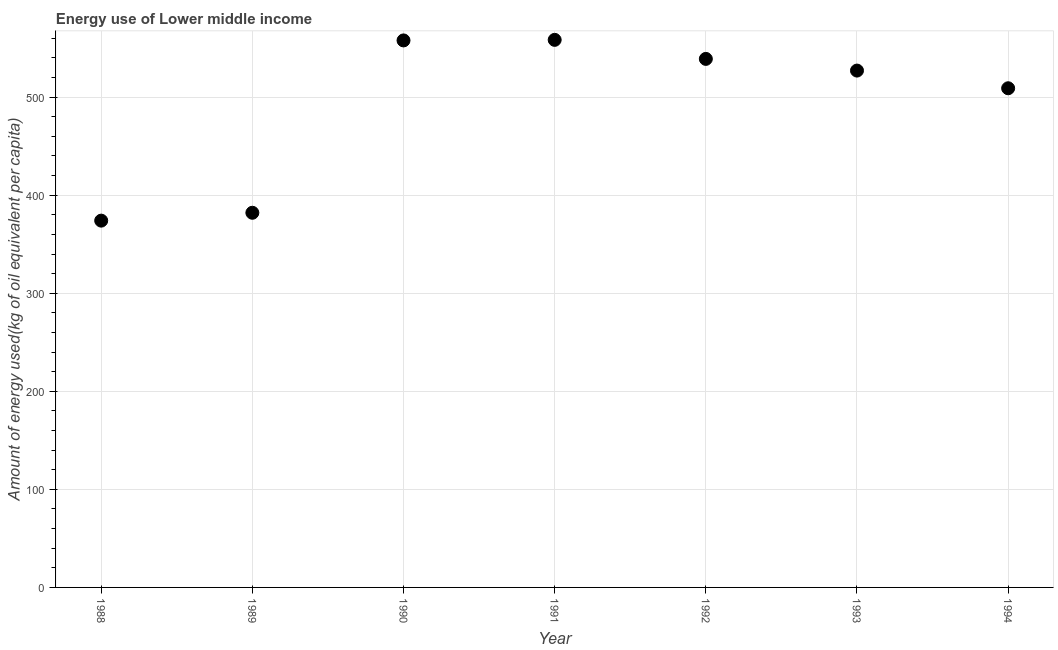What is the amount of energy used in 1989?
Provide a succinct answer. 382.1. Across all years, what is the maximum amount of energy used?
Your response must be concise. 558.43. Across all years, what is the minimum amount of energy used?
Your answer should be compact. 374.07. In which year was the amount of energy used maximum?
Make the answer very short. 1991. In which year was the amount of energy used minimum?
Your answer should be very brief. 1988. What is the sum of the amount of energy used?
Provide a short and direct response. 3447.65. What is the difference between the amount of energy used in 1991 and 1994?
Make the answer very short. 49.36. What is the average amount of energy used per year?
Provide a succinct answer. 492.52. What is the median amount of energy used?
Make the answer very short. 527.1. What is the ratio of the amount of energy used in 1991 to that in 1993?
Make the answer very short. 1.06. What is the difference between the highest and the second highest amount of energy used?
Ensure brevity in your answer.  0.57. Is the sum of the amount of energy used in 1990 and 1993 greater than the maximum amount of energy used across all years?
Your answer should be very brief. Yes. What is the difference between the highest and the lowest amount of energy used?
Provide a short and direct response. 184.36. How many years are there in the graph?
Provide a succinct answer. 7. What is the difference between two consecutive major ticks on the Y-axis?
Your answer should be very brief. 100. Are the values on the major ticks of Y-axis written in scientific E-notation?
Offer a terse response. No. Does the graph contain any zero values?
Provide a succinct answer. No. Does the graph contain grids?
Ensure brevity in your answer.  Yes. What is the title of the graph?
Your answer should be compact. Energy use of Lower middle income. What is the label or title of the X-axis?
Ensure brevity in your answer.  Year. What is the label or title of the Y-axis?
Ensure brevity in your answer.  Amount of energy used(kg of oil equivalent per capita). What is the Amount of energy used(kg of oil equivalent per capita) in 1988?
Offer a terse response. 374.07. What is the Amount of energy used(kg of oil equivalent per capita) in 1989?
Make the answer very short. 382.1. What is the Amount of energy used(kg of oil equivalent per capita) in 1990?
Offer a terse response. 557.86. What is the Amount of energy used(kg of oil equivalent per capita) in 1991?
Ensure brevity in your answer.  558.43. What is the Amount of energy used(kg of oil equivalent per capita) in 1992?
Your response must be concise. 539.02. What is the Amount of energy used(kg of oil equivalent per capita) in 1993?
Offer a terse response. 527.1. What is the Amount of energy used(kg of oil equivalent per capita) in 1994?
Your answer should be very brief. 509.07. What is the difference between the Amount of energy used(kg of oil equivalent per capita) in 1988 and 1989?
Ensure brevity in your answer.  -8.02. What is the difference between the Amount of energy used(kg of oil equivalent per capita) in 1988 and 1990?
Make the answer very short. -183.79. What is the difference between the Amount of energy used(kg of oil equivalent per capita) in 1988 and 1991?
Ensure brevity in your answer.  -184.36. What is the difference between the Amount of energy used(kg of oil equivalent per capita) in 1988 and 1992?
Provide a short and direct response. -164.95. What is the difference between the Amount of energy used(kg of oil equivalent per capita) in 1988 and 1993?
Ensure brevity in your answer.  -153.03. What is the difference between the Amount of energy used(kg of oil equivalent per capita) in 1988 and 1994?
Your answer should be compact. -135. What is the difference between the Amount of energy used(kg of oil equivalent per capita) in 1989 and 1990?
Offer a terse response. -175.77. What is the difference between the Amount of energy used(kg of oil equivalent per capita) in 1989 and 1991?
Make the answer very short. -176.34. What is the difference between the Amount of energy used(kg of oil equivalent per capita) in 1989 and 1992?
Your answer should be compact. -156.92. What is the difference between the Amount of energy used(kg of oil equivalent per capita) in 1989 and 1993?
Your answer should be very brief. -145.01. What is the difference between the Amount of energy used(kg of oil equivalent per capita) in 1989 and 1994?
Keep it short and to the point. -126.98. What is the difference between the Amount of energy used(kg of oil equivalent per capita) in 1990 and 1991?
Your answer should be very brief. -0.57. What is the difference between the Amount of energy used(kg of oil equivalent per capita) in 1990 and 1992?
Ensure brevity in your answer.  18.85. What is the difference between the Amount of energy used(kg of oil equivalent per capita) in 1990 and 1993?
Your response must be concise. 30.76. What is the difference between the Amount of energy used(kg of oil equivalent per capita) in 1990 and 1994?
Offer a very short reply. 48.79. What is the difference between the Amount of energy used(kg of oil equivalent per capita) in 1991 and 1992?
Provide a succinct answer. 19.42. What is the difference between the Amount of energy used(kg of oil equivalent per capita) in 1991 and 1993?
Provide a short and direct response. 31.33. What is the difference between the Amount of energy used(kg of oil equivalent per capita) in 1991 and 1994?
Provide a succinct answer. 49.36. What is the difference between the Amount of energy used(kg of oil equivalent per capita) in 1992 and 1993?
Offer a terse response. 11.91. What is the difference between the Amount of energy used(kg of oil equivalent per capita) in 1992 and 1994?
Your answer should be very brief. 29.94. What is the difference between the Amount of energy used(kg of oil equivalent per capita) in 1993 and 1994?
Your answer should be compact. 18.03. What is the ratio of the Amount of energy used(kg of oil equivalent per capita) in 1988 to that in 1989?
Make the answer very short. 0.98. What is the ratio of the Amount of energy used(kg of oil equivalent per capita) in 1988 to that in 1990?
Keep it short and to the point. 0.67. What is the ratio of the Amount of energy used(kg of oil equivalent per capita) in 1988 to that in 1991?
Your answer should be very brief. 0.67. What is the ratio of the Amount of energy used(kg of oil equivalent per capita) in 1988 to that in 1992?
Keep it short and to the point. 0.69. What is the ratio of the Amount of energy used(kg of oil equivalent per capita) in 1988 to that in 1993?
Provide a succinct answer. 0.71. What is the ratio of the Amount of energy used(kg of oil equivalent per capita) in 1988 to that in 1994?
Keep it short and to the point. 0.73. What is the ratio of the Amount of energy used(kg of oil equivalent per capita) in 1989 to that in 1990?
Keep it short and to the point. 0.69. What is the ratio of the Amount of energy used(kg of oil equivalent per capita) in 1989 to that in 1991?
Provide a succinct answer. 0.68. What is the ratio of the Amount of energy used(kg of oil equivalent per capita) in 1989 to that in 1992?
Offer a very short reply. 0.71. What is the ratio of the Amount of energy used(kg of oil equivalent per capita) in 1989 to that in 1993?
Your response must be concise. 0.72. What is the ratio of the Amount of energy used(kg of oil equivalent per capita) in 1989 to that in 1994?
Your answer should be very brief. 0.75. What is the ratio of the Amount of energy used(kg of oil equivalent per capita) in 1990 to that in 1991?
Keep it short and to the point. 1. What is the ratio of the Amount of energy used(kg of oil equivalent per capita) in 1990 to that in 1992?
Provide a short and direct response. 1.03. What is the ratio of the Amount of energy used(kg of oil equivalent per capita) in 1990 to that in 1993?
Ensure brevity in your answer.  1.06. What is the ratio of the Amount of energy used(kg of oil equivalent per capita) in 1990 to that in 1994?
Provide a succinct answer. 1.1. What is the ratio of the Amount of energy used(kg of oil equivalent per capita) in 1991 to that in 1992?
Provide a succinct answer. 1.04. What is the ratio of the Amount of energy used(kg of oil equivalent per capita) in 1991 to that in 1993?
Your answer should be compact. 1.06. What is the ratio of the Amount of energy used(kg of oil equivalent per capita) in 1991 to that in 1994?
Your answer should be compact. 1.1. What is the ratio of the Amount of energy used(kg of oil equivalent per capita) in 1992 to that in 1994?
Offer a very short reply. 1.06. What is the ratio of the Amount of energy used(kg of oil equivalent per capita) in 1993 to that in 1994?
Your answer should be compact. 1.03. 